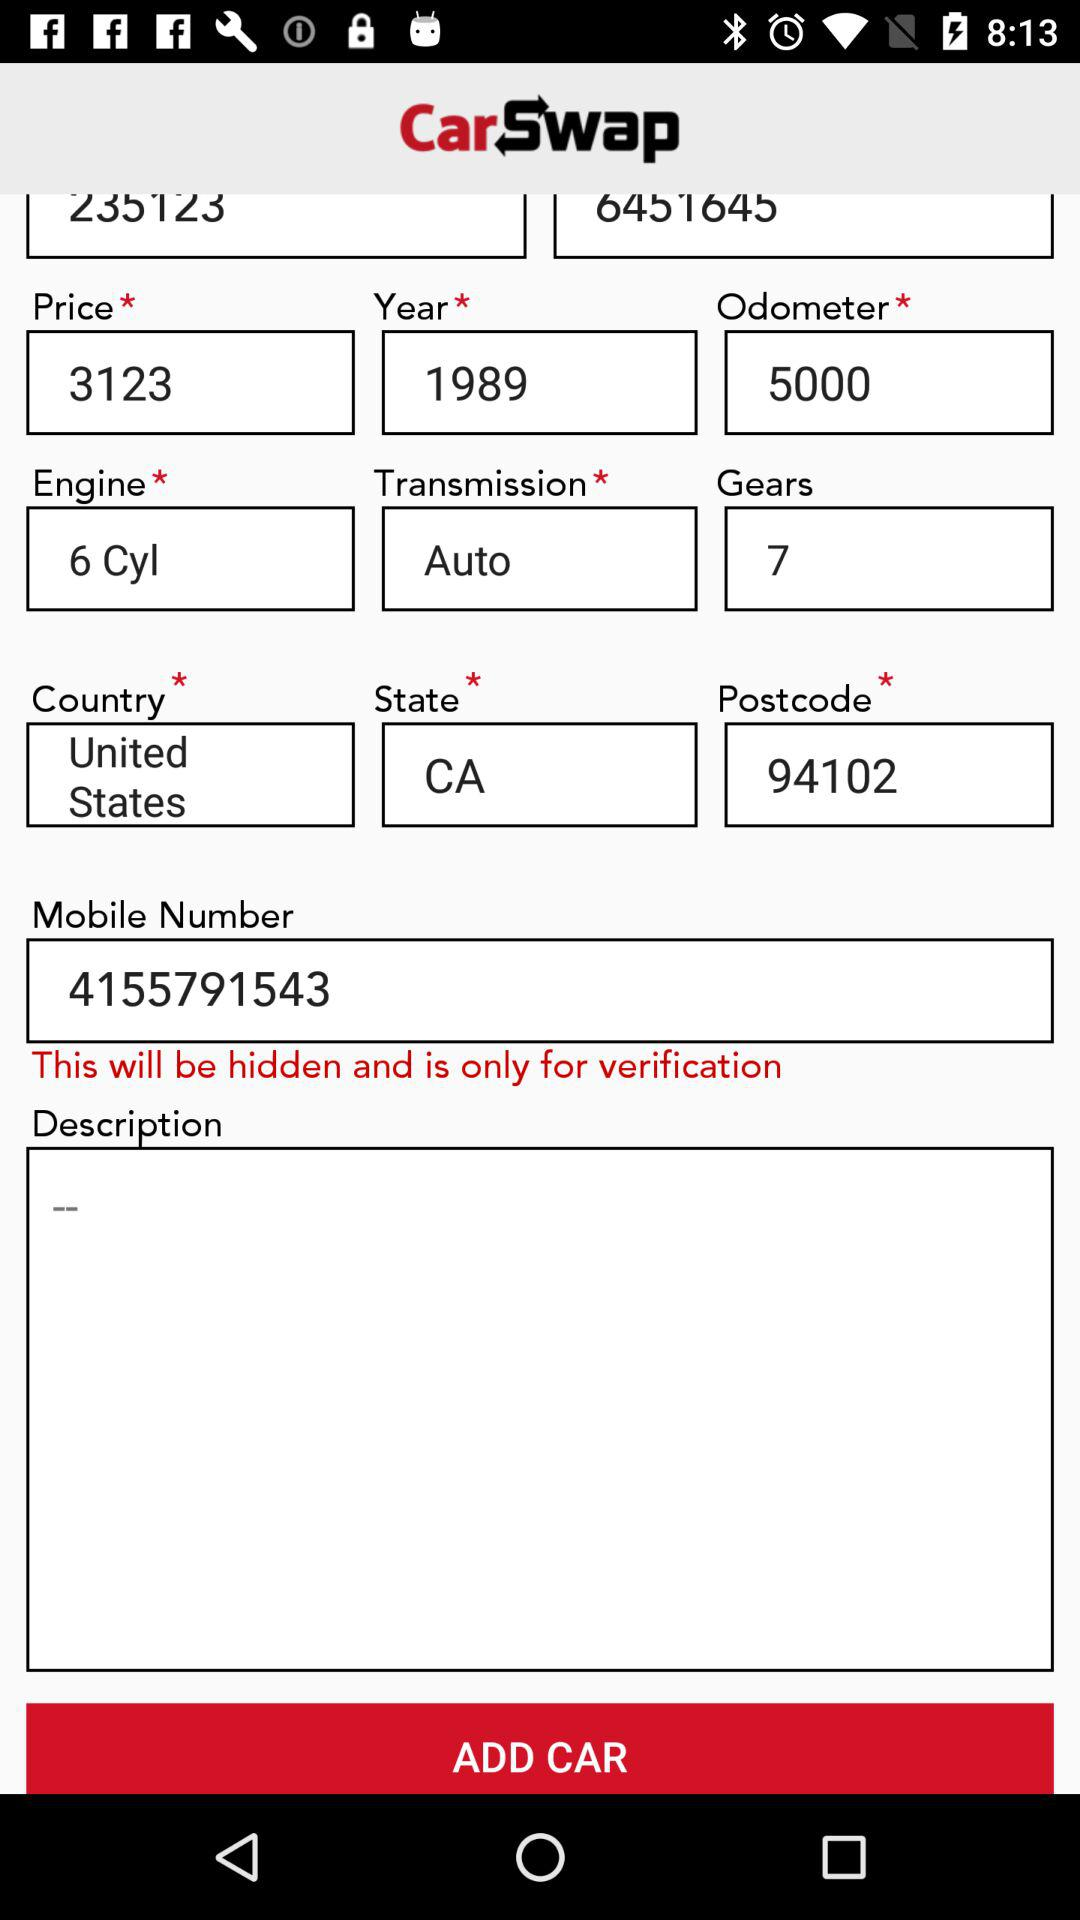What is the postcode? The postcode is 94102. 